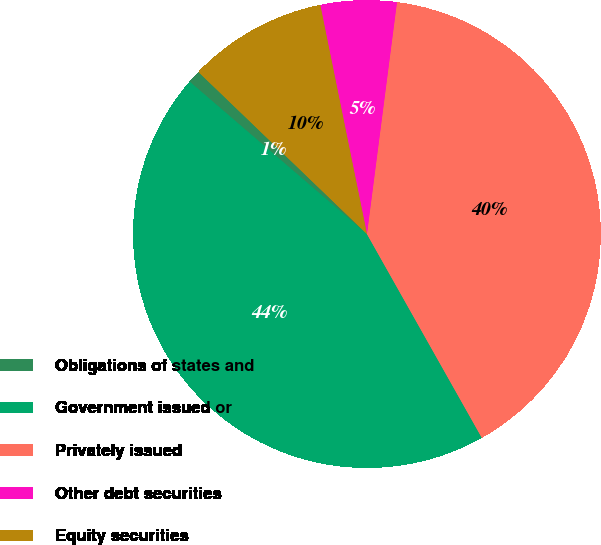<chart> <loc_0><loc_0><loc_500><loc_500><pie_chart><fcel>Obligations of states and<fcel>Government issued or<fcel>Privately issued<fcel>Other debt securities<fcel>Equity securities<nl><fcel>0.89%<fcel>44.47%<fcel>39.78%<fcel>5.25%<fcel>9.61%<nl></chart> 